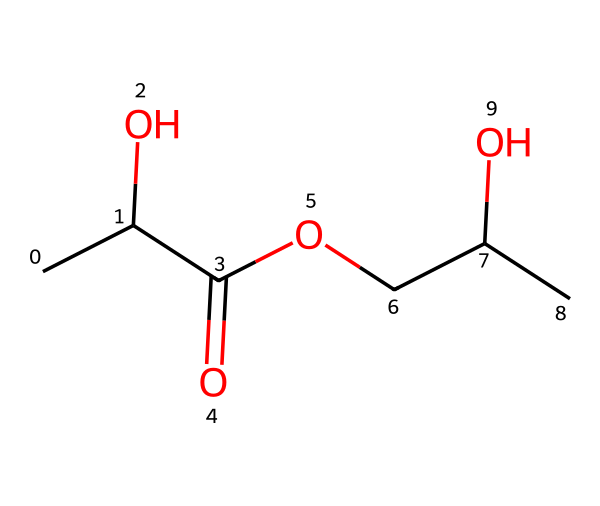how many carbon atoms are in this structure? To determine the number of carbon atoms, count the 'C' symbols in the SMILES representation. There are five 'C' symbols in total, indicating there are five carbon atoms in the structure.
Answer: five what functional groups are present in this chemical? The chemical contains a hydroxyl group (–OH) indicated by 'O' attached to 'C', and a carboxyl group (–COOH) indicated by 'C(=O)O'. This shows both alcohol and acid functional groups are present.
Answer: hydroxyl and carboxyl what is the degree of saturation of this structure? The degree of saturation can be calculated by checking the number of double bonds and rings. In this SMILES structure, there is one double bond (C(=O)) and no rings, contributing to a degree of saturation of 2.
Answer: 2 is this polymer likely to be biodegradable? The presence of aliphatic carbon chains and functional groups like carboxyl and hydroxyl in the structure indicates it can be hydrolyzed. This suggests that it will break down in the environment, confirming its biodegradability.
Answer: yes what type of polymer does this chemical represent? The presence of multiple hydroxyl (–OH) and carboxylic (–COOH) functional groups suggests that this is a polyol or polyacid type polymer, often used in creating biodegradable plastics.
Answer: polyol or polyacid what structural feature indicates this material can be used for disposable cutlery? The presence of a simple aliphatic backbone and functional groups contributing to strength and flexibility make it suitable for manufacturing disposable cutlery, indicating structural integrity and ease of shaping.
Answer: aliphatic backbone 